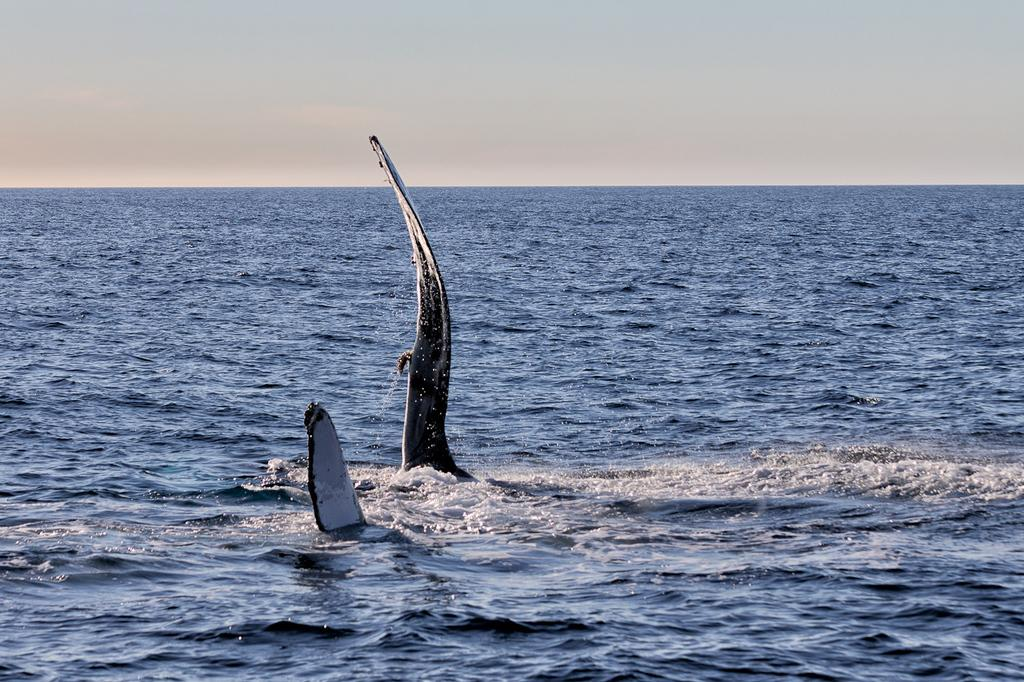What type of animals can be seen in the image? There are aquatic animals in the image. Where are the aquatic animals located? The aquatic animals are in the water. What is the color of the sky in the image? The sky is white in color. How many fingers can be seen pointing at the aquatic animals in the image? There are no fingers visible in the image, as it features aquatic animals in the water with a white sky. 